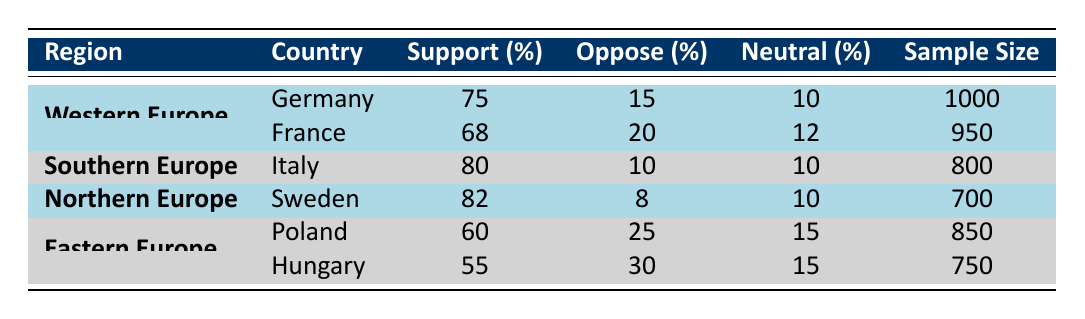What is the percentage of support for vaccine equity in Germany? The table indicates that the respective percentage of support for vaccine equity in Germany is directly listed under the "Support (%)" column, where it shows 75%.
Answer: 75% Which country in Southern Europe has the highest support for vaccine equity? According to the table, Italy has a support percentage of 80%, whereas no other Southern European country is listed, making it the highest in that region for vaccine equity support.
Answer: Italy How many people opposed equity in Hungary? The table shows that 30% of the respondents in Hungary opposed vaccine equity, which is listed under the "Oppose (%)" column for that country.
Answer: 30% What is the average support percentage for vaccine equity in Eastern Europe? To find the average support percentage in Eastern Europe, we take the support percentages of Poland (60%) and Hungary (55%), sum them (60 + 55 = 115), and then divide by the number of countries which is 2. Therefore, the average is 115/2 = 57.5%.
Answer: 57.5% Is there a country in Northern Europe that has a support percentage equal to or greater than 80%? The table indicates that Sweden has a support percentage of 82%, which is greater than 80%, confirming that yes, there is a country in Northern Europe that meets this requirement.
Answer: Yes What is the total sample size for the countries in Western Europe? The total sample size for Western Europe can be calculated by adding the sample sizes for Germany (1000) and France (950), resulting in 1000 + 950 = 1950.
Answer: 1950 How many people are neutral about vaccine equity in Italy? The data indicates that 10% of the respondents in Italy are neutral regarding vaccine equity, which is stated under the "Neutral (%)" column. Given the focus group size of 800, this corresponds to 0.10 * 800 = 80 people who are neutral.
Answer: 80 Which country has the lowest percentage of support for vaccine equity among the presented countries? By examining the support percentages across all the listed countries, Hungary has the lowest percentage at 55%, making it the country with the least support for vaccine equity.
Answer: Hungary 